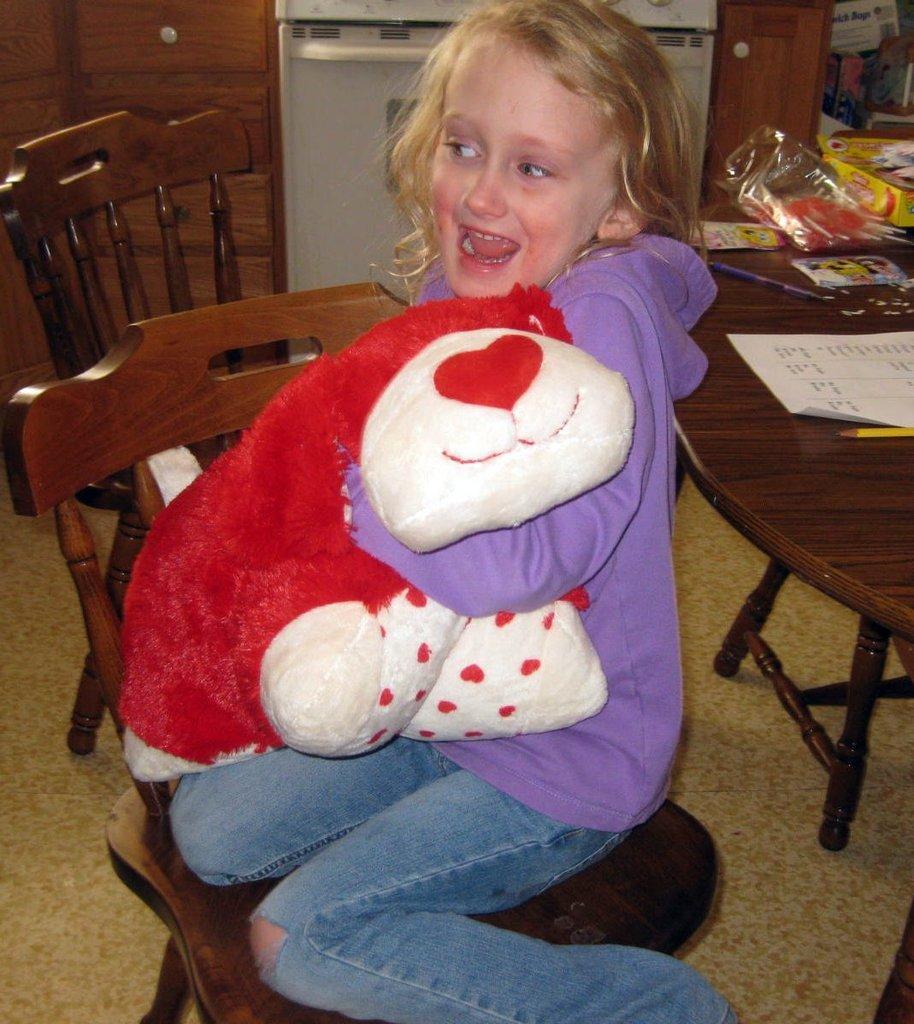How would you summarize this image in a sentence or two? As we can see in the image, there is a girl sitting on chair and holding doll in her hand. On the right side side there is a dining table. On dining table there is a yellow colored pencil, paper and some covers. 